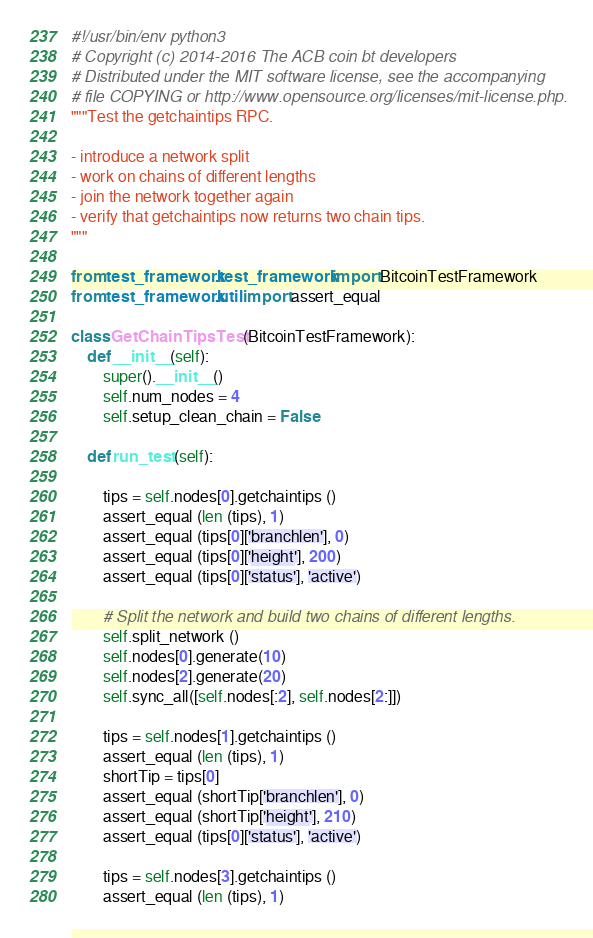<code> <loc_0><loc_0><loc_500><loc_500><_Python_>#!/usr/bin/env python3
# Copyright (c) 2014-2016 The ACB coin bt developers
# Distributed under the MIT software license, see the accompanying
# file COPYING or http://www.opensource.org/licenses/mit-license.php.
"""Test the getchaintips RPC.

- introduce a network split
- work on chains of different lengths
- join the network together again
- verify that getchaintips now returns two chain tips.
"""

from test_framework.test_framework import BitcoinTestFramework
from test_framework.util import assert_equal

class GetChainTipsTest (BitcoinTestFramework):
    def __init__(self):
        super().__init__()
        self.num_nodes = 4
        self.setup_clean_chain = False

    def run_test (self):

        tips = self.nodes[0].getchaintips ()
        assert_equal (len (tips), 1)
        assert_equal (tips[0]['branchlen'], 0)
        assert_equal (tips[0]['height'], 200)
        assert_equal (tips[0]['status'], 'active')

        # Split the network and build two chains of different lengths.
        self.split_network ()
        self.nodes[0].generate(10)
        self.nodes[2].generate(20)
        self.sync_all([self.nodes[:2], self.nodes[2:]])

        tips = self.nodes[1].getchaintips ()
        assert_equal (len (tips), 1)
        shortTip = tips[0]
        assert_equal (shortTip['branchlen'], 0)
        assert_equal (shortTip['height'], 210)
        assert_equal (tips[0]['status'], 'active')

        tips = self.nodes[3].getchaintips ()
        assert_equal (len (tips), 1)</code> 